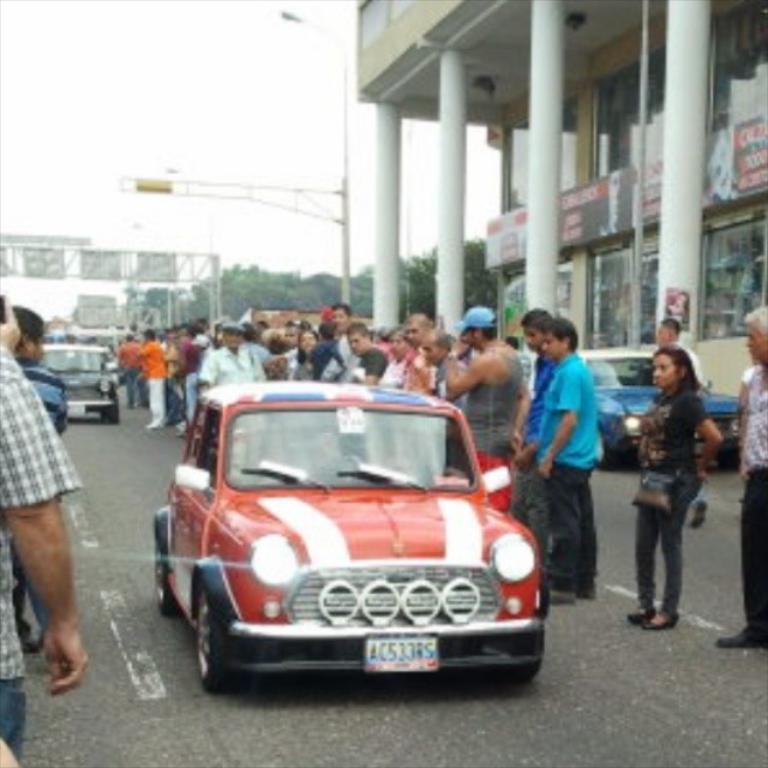Can you describe this image briefly? In this image there is the sky truncated towards the top of the image, there are poles, there are boards truncated towards the left of the image, there is a street light, there is a building truncated towards the right of the image, there are boards truncated towards the right of the image, there is text on the board, there are pillars truncated towards the top of the image, there are group of persons on the road, there is a person truncated towards the right of the image, there are persons truncated towards the left of the image, there are vehicles on the road, there are trees. 